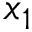Convert formula to latex. <formula><loc_0><loc_0><loc_500><loc_500>x _ { 1 }</formula> 